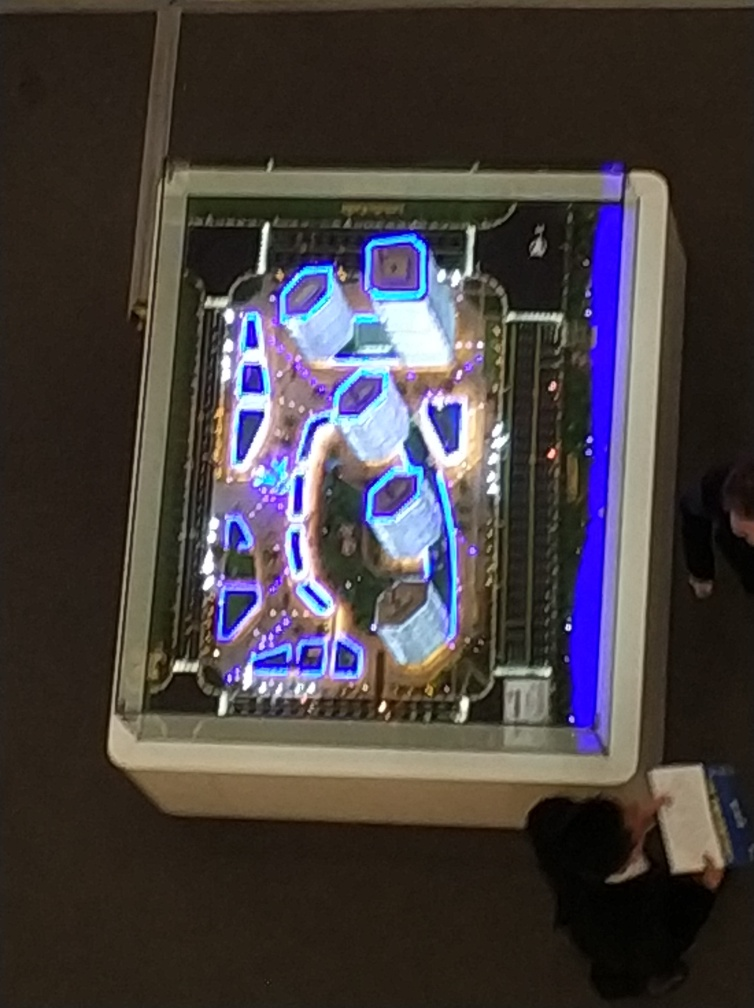What time of day does it seem to be in this picture? Given the image's dim surroundings contrasted by the brightness of the lights, it suggests that the photo was taken during the evening or at night. Are there people in the image? Yes, there are a few individuals present. One person appears prominently at the bottom right, providing a sense of scale and human element to the scene. 